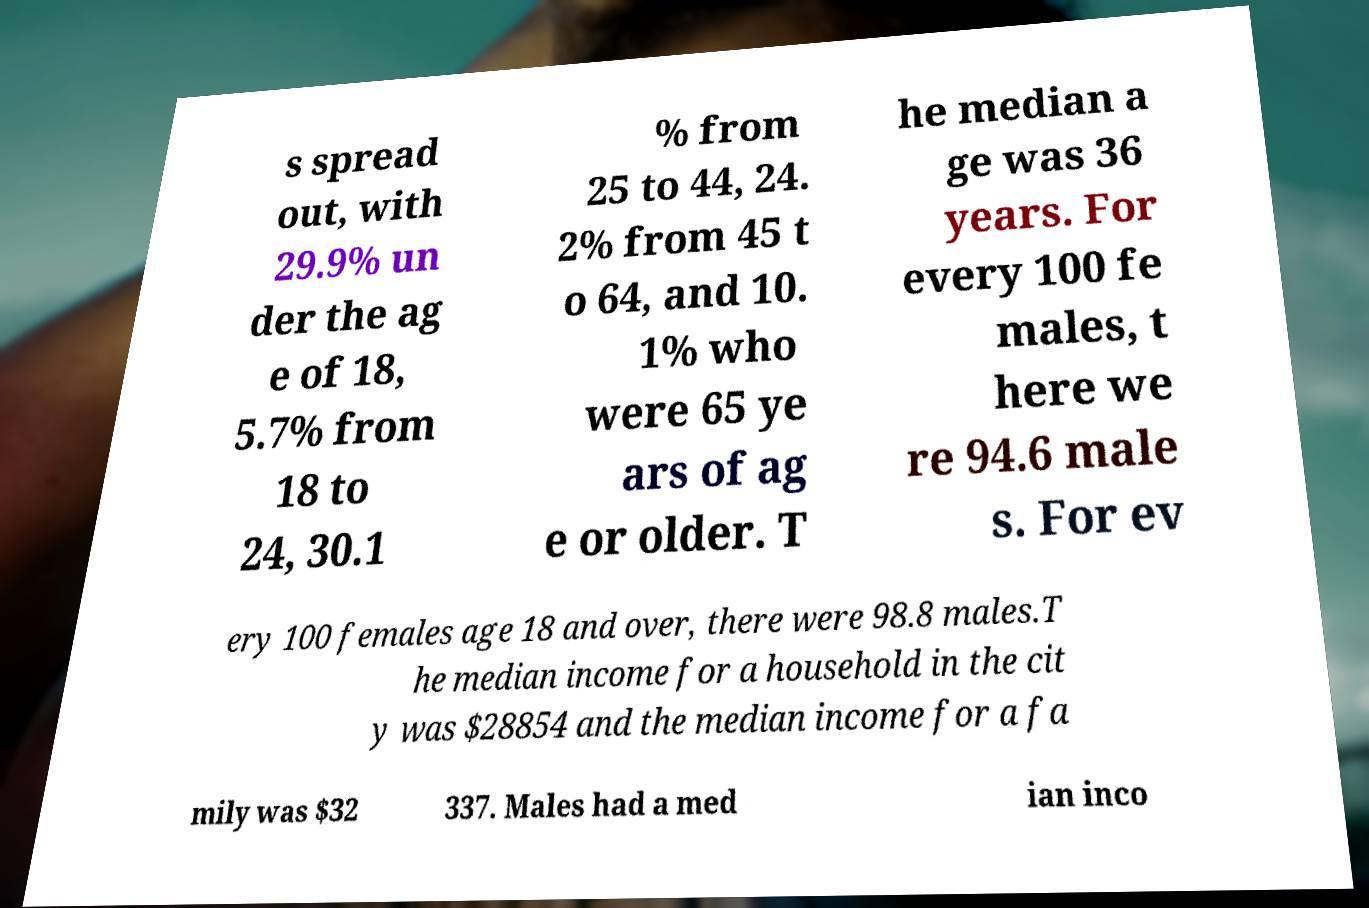Can you accurately transcribe the text from the provided image for me? s spread out, with 29.9% un der the ag e of 18, 5.7% from 18 to 24, 30.1 % from 25 to 44, 24. 2% from 45 t o 64, and 10. 1% who were 65 ye ars of ag e or older. T he median a ge was 36 years. For every 100 fe males, t here we re 94.6 male s. For ev ery 100 females age 18 and over, there were 98.8 males.T he median income for a household in the cit y was $28854 and the median income for a fa mily was $32 337. Males had a med ian inco 